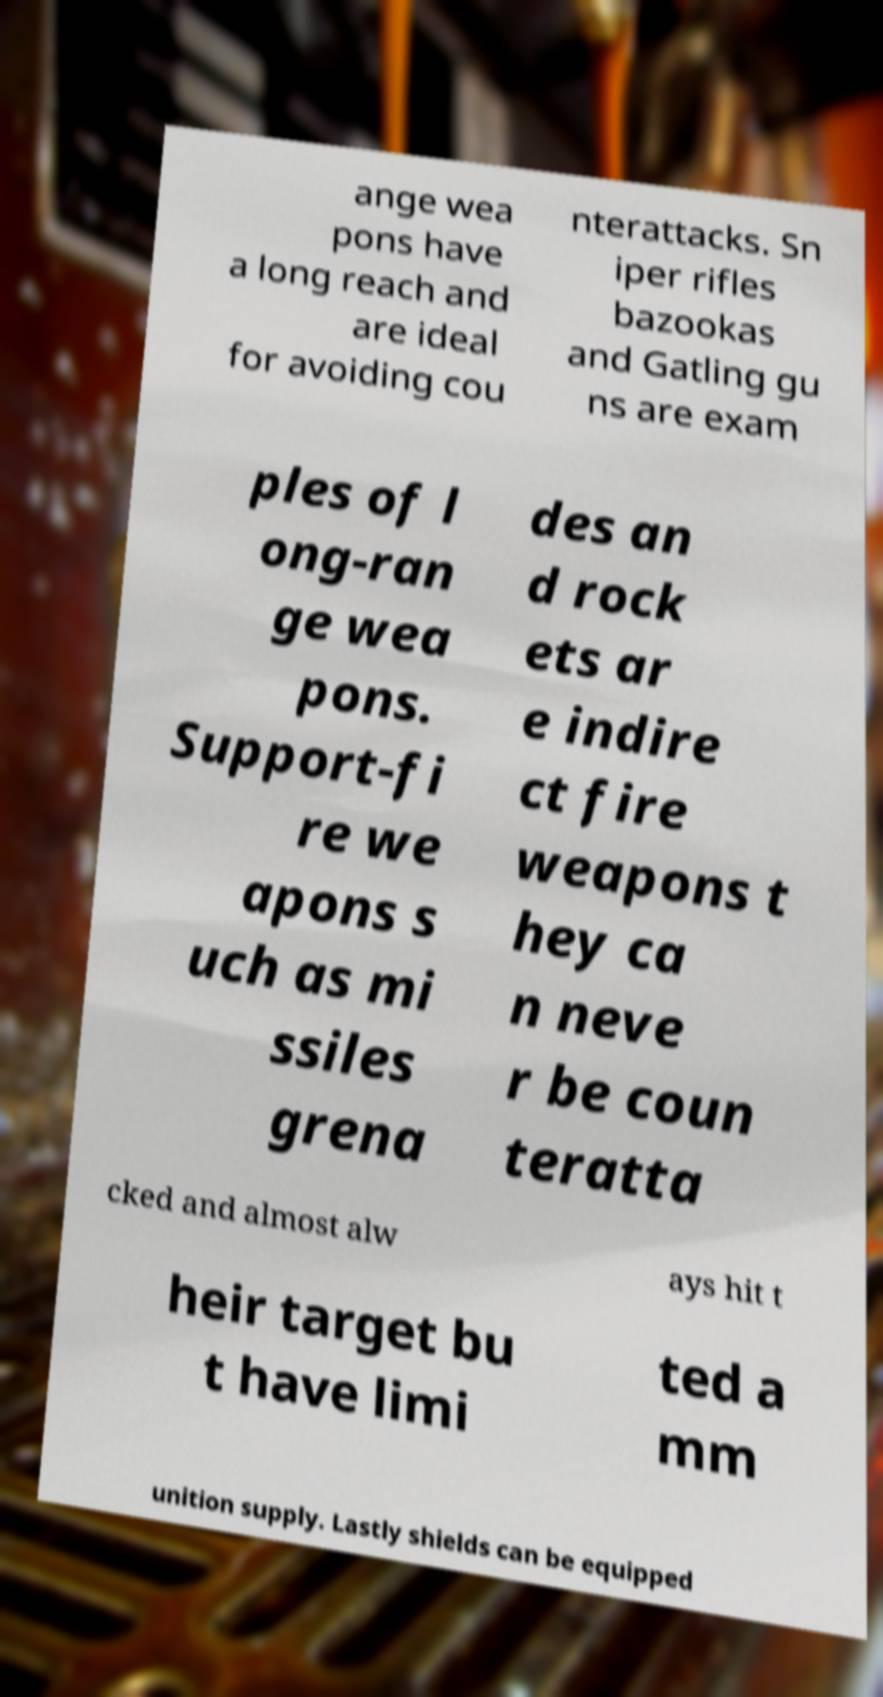Could you assist in decoding the text presented in this image and type it out clearly? ange wea pons have a long reach and are ideal for avoiding cou nterattacks. Sn iper rifles bazookas and Gatling gu ns are exam ples of l ong-ran ge wea pons. Support-fi re we apons s uch as mi ssiles grena des an d rock ets ar e indire ct fire weapons t hey ca n neve r be coun teratta cked and almost alw ays hit t heir target bu t have limi ted a mm unition supply. Lastly shields can be equipped 